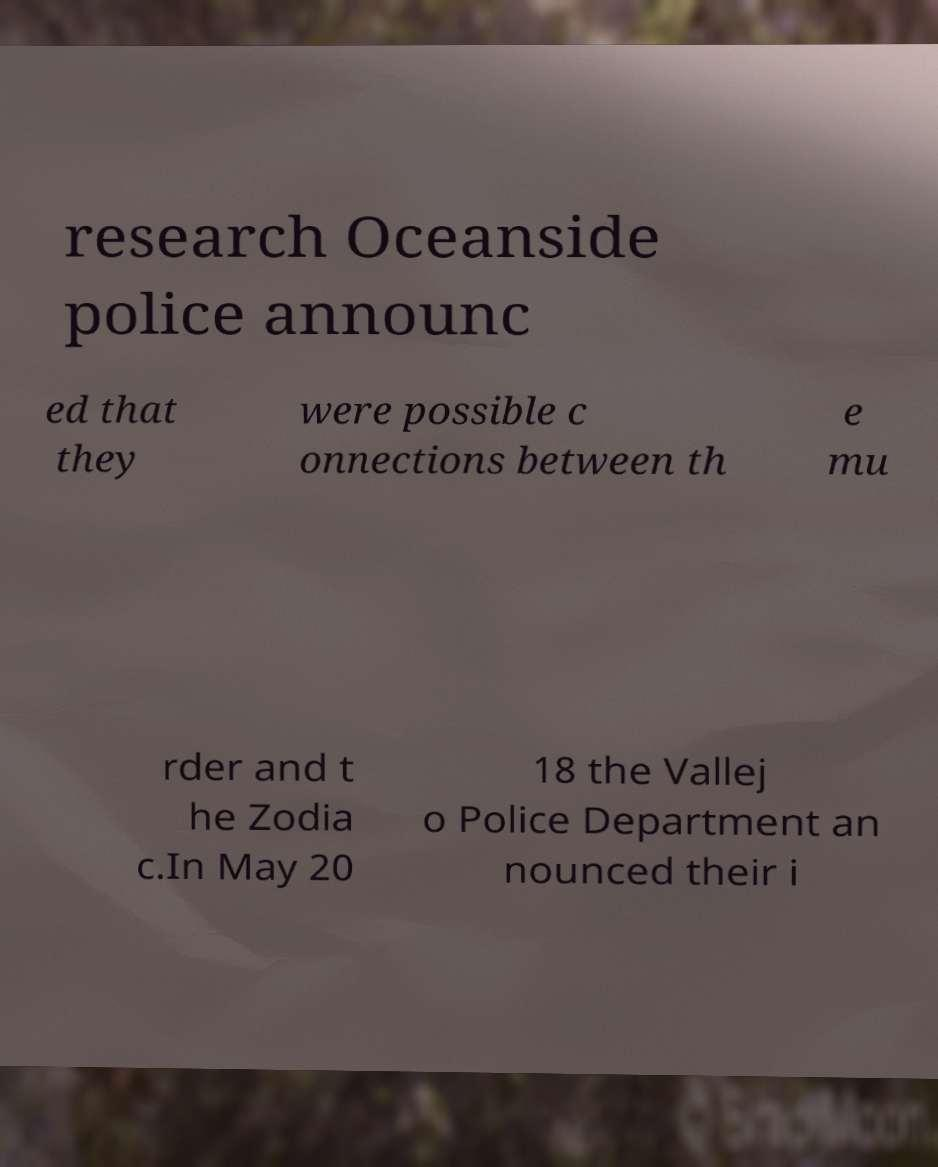Please identify and transcribe the text found in this image. research Oceanside police announc ed that they were possible c onnections between th e mu rder and t he Zodia c.In May 20 18 the Vallej o Police Department an nounced their i 